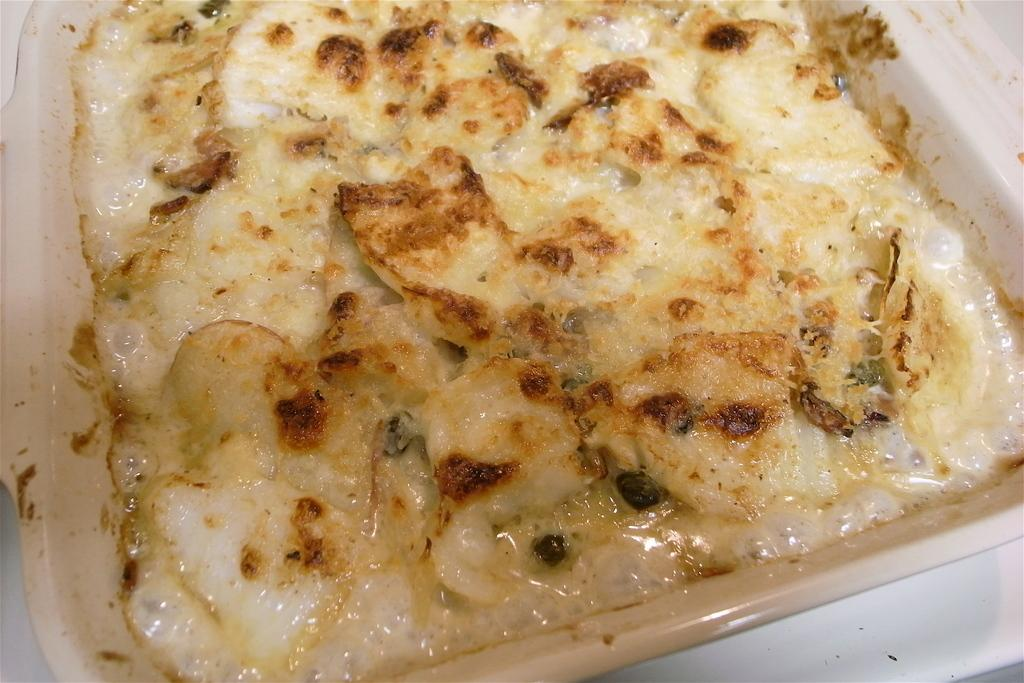What is present in the image? There is food in the image. How is the food arranged or contained? The food is in a tray. What type of feather can be seen on the food in the image? There is no feather present on the food in the image. How does the daughter interact with the food in the image? There is no daughter present in the image, so it is not possible to describe any interaction with the food. 